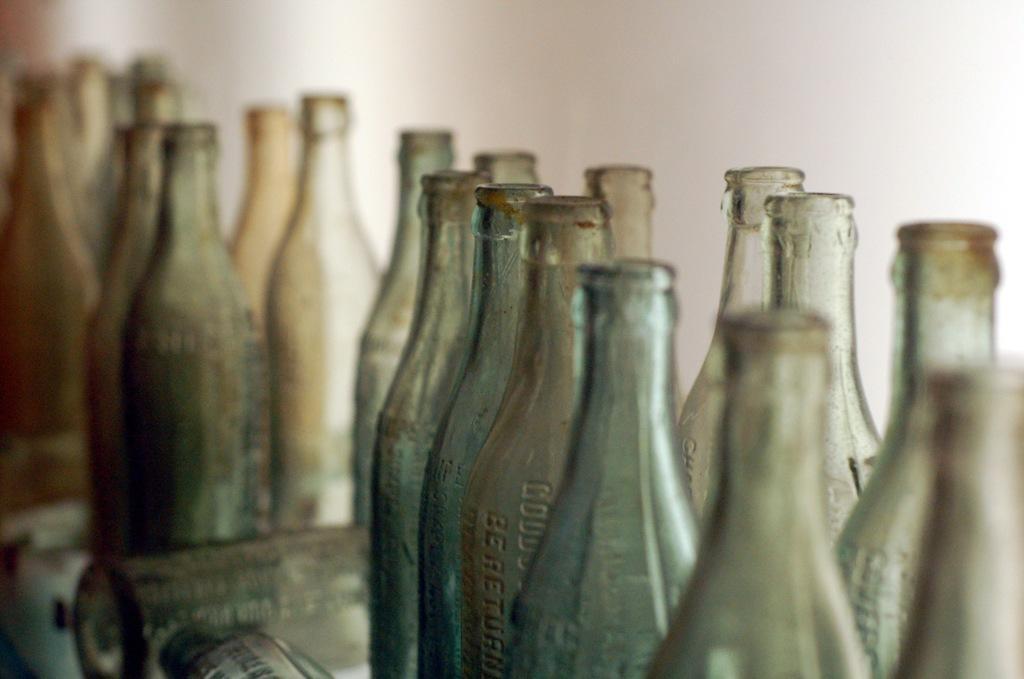Describe this image in one or two sentences. In this image there are many bottles placed on the table. 